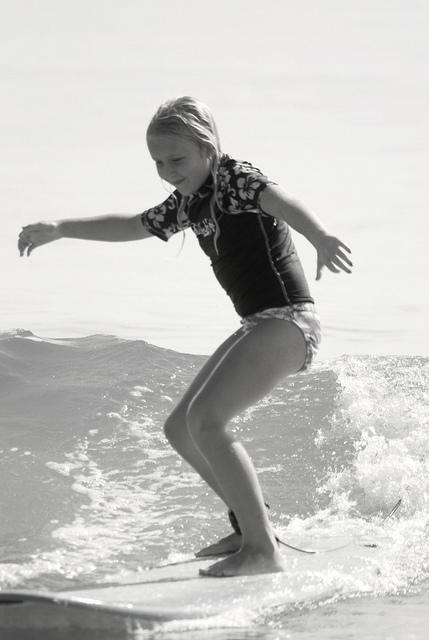What is the girl doing?
Keep it brief. Surfing. Where is the girl on the surfboard?
Answer briefly. Ocean. Is the photo colored?
Quick response, please. No. 